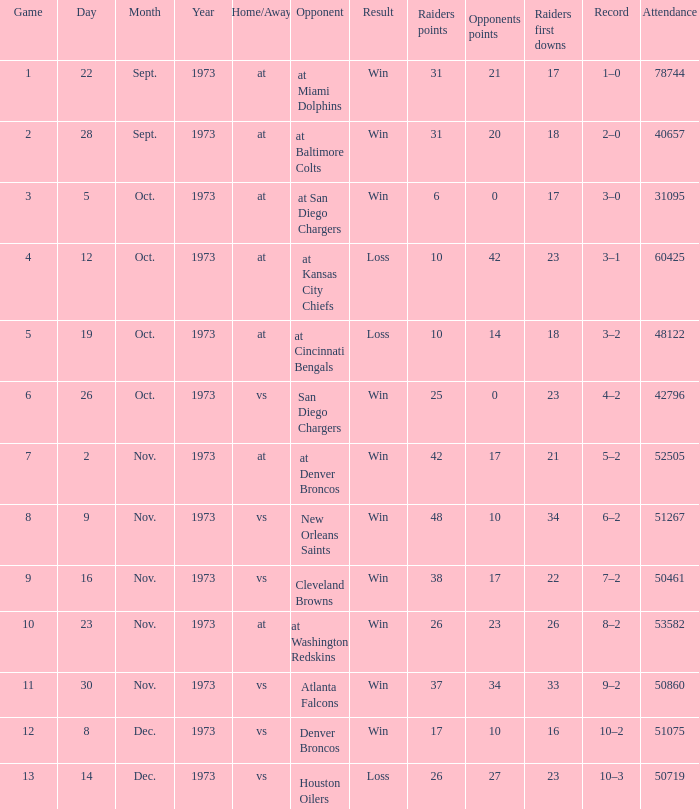Who was the game attended by 60425 people played against? At kansas city chiefs. 